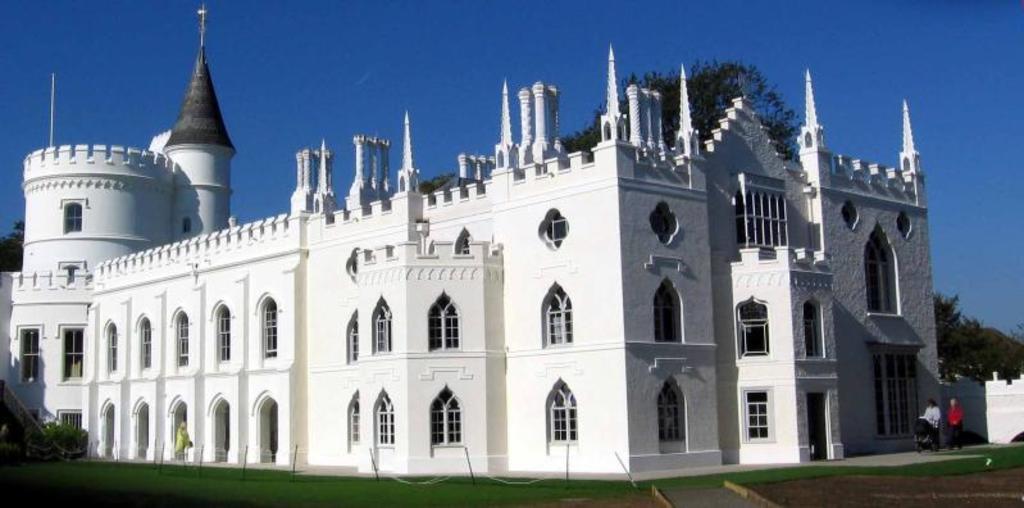In one or two sentences, can you explain what this image depicts? In this image, I can see a building. On the right side of the image, there are two persons standing and I can see a stroller. At the bottom of the image, I can see the plants, grass and poles. Behind the building, there are trees. In the background, there is the sky. 